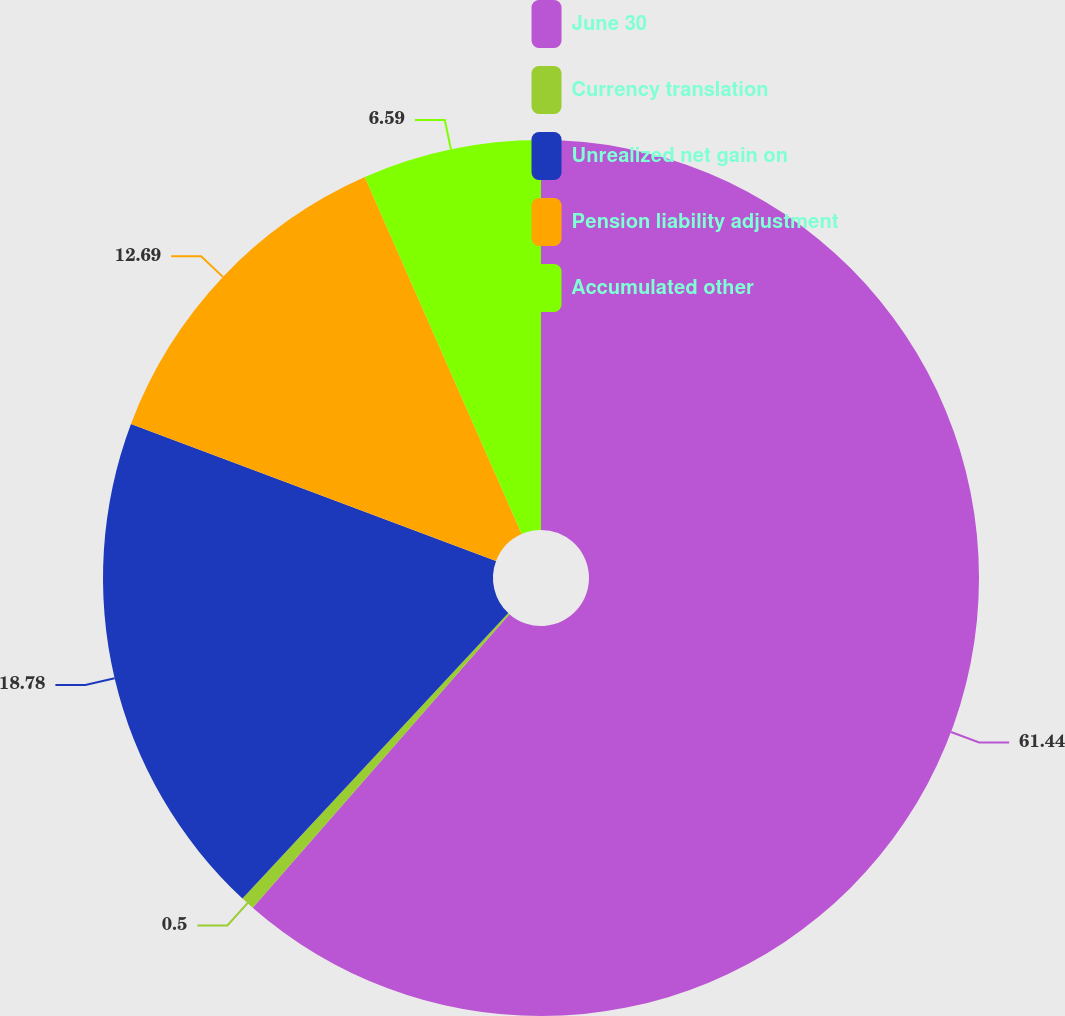Convert chart to OTSL. <chart><loc_0><loc_0><loc_500><loc_500><pie_chart><fcel>June 30<fcel>Currency translation<fcel>Unrealized net gain on<fcel>Pension liability adjustment<fcel>Accumulated other<nl><fcel>61.43%<fcel>0.5%<fcel>18.78%<fcel>12.69%<fcel>6.59%<nl></chart> 